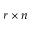<formula> <loc_0><loc_0><loc_500><loc_500>r \times n</formula> 